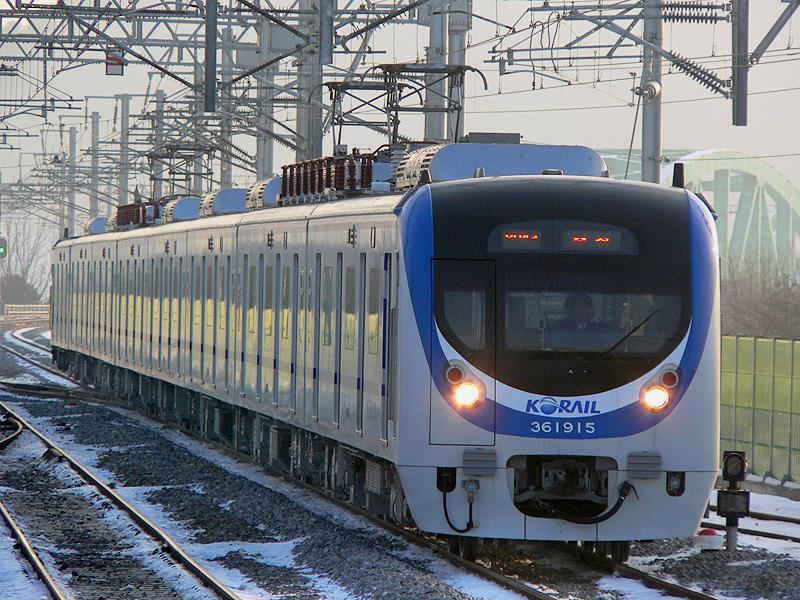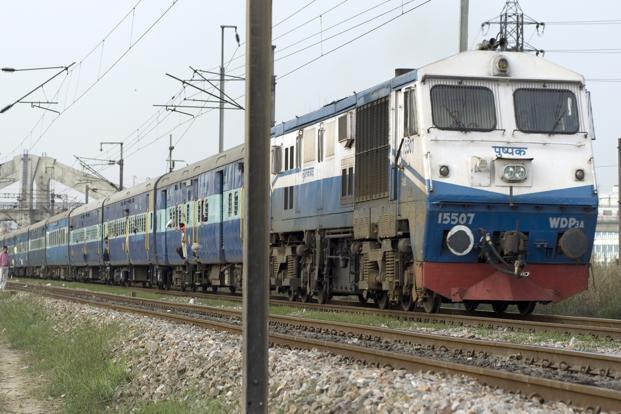The first image is the image on the left, the second image is the image on the right. Evaluate the accuracy of this statement regarding the images: "All of the trains are electric.". Is it true? Answer yes or no. Yes. 